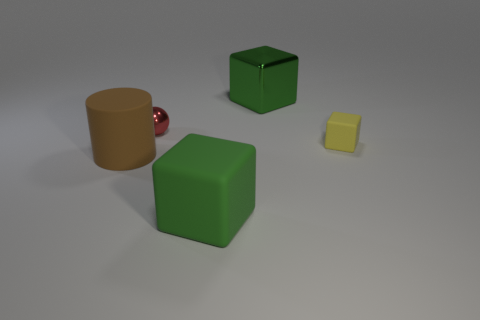Does the yellow matte thing have the same shape as the green rubber object?
Offer a terse response. Yes. There is a sphere; are there any green blocks behind it?
Your response must be concise. Yes. Does the large green thing that is behind the red ball have the same shape as the large brown rubber object?
Make the answer very short. No. There is another block that is the same color as the metal block; what is it made of?
Provide a short and direct response. Rubber. How many shiny things are the same color as the big rubber block?
Your answer should be very brief. 1. There is a rubber thing to the right of the big green block behind the yellow rubber object; what is its shape?
Offer a terse response. Cube. Is there a tiny yellow matte object of the same shape as the big green metallic object?
Keep it short and to the point. Yes. Is the color of the matte cylinder the same as the large object that is behind the small red object?
Keep it short and to the point. No. There is a metal object that is the same color as the large matte cube; what size is it?
Your answer should be compact. Large. Is there a green metal cube that has the same size as the yellow thing?
Your answer should be compact. No. 